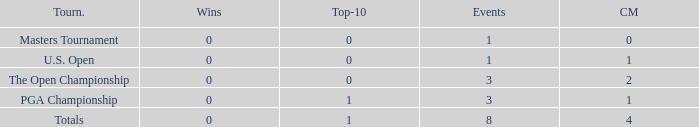For events with under 3 times played and fewer than 1 cut made, what is the total number of top-10 finishes? 1.0. 